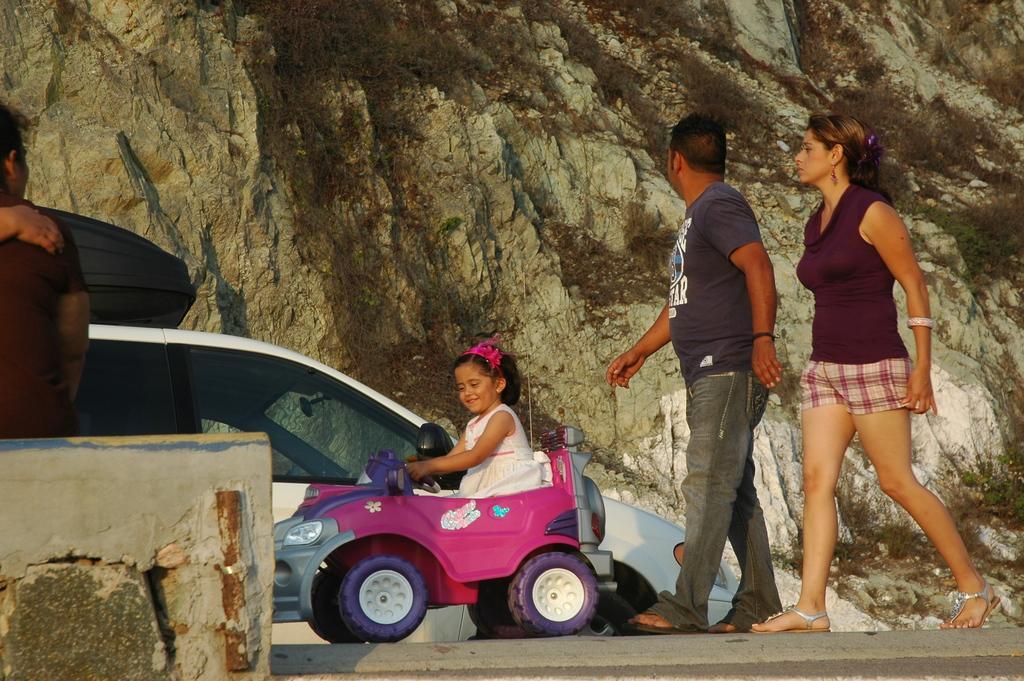In one or two sentences, can you explain what this image depicts? There are two members walking on a road. One is woman and other one is a man. In Front of them there is a girl driving a toy car. In the background we can observe a car moving and a hill here. In the left side there is another man sitting on a wall. 